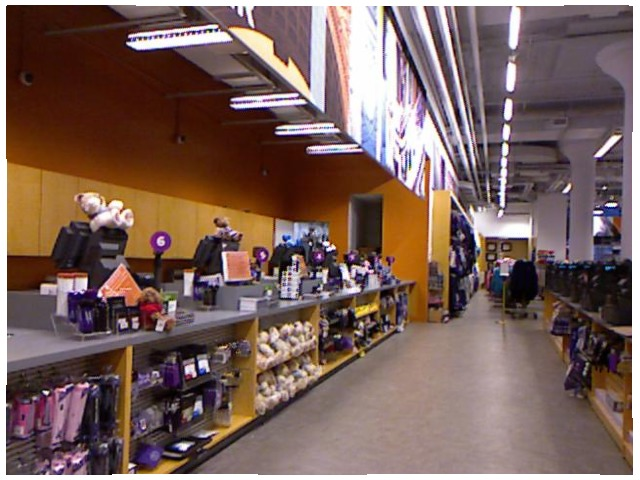<image>
Is there a teddy on the register? Yes. Looking at the image, I can see the teddy is positioned on top of the register, with the register providing support. Where is the doll in relation to the cupboard? Is it on the cupboard? Yes. Looking at the image, I can see the doll is positioned on top of the cupboard, with the cupboard providing support. 